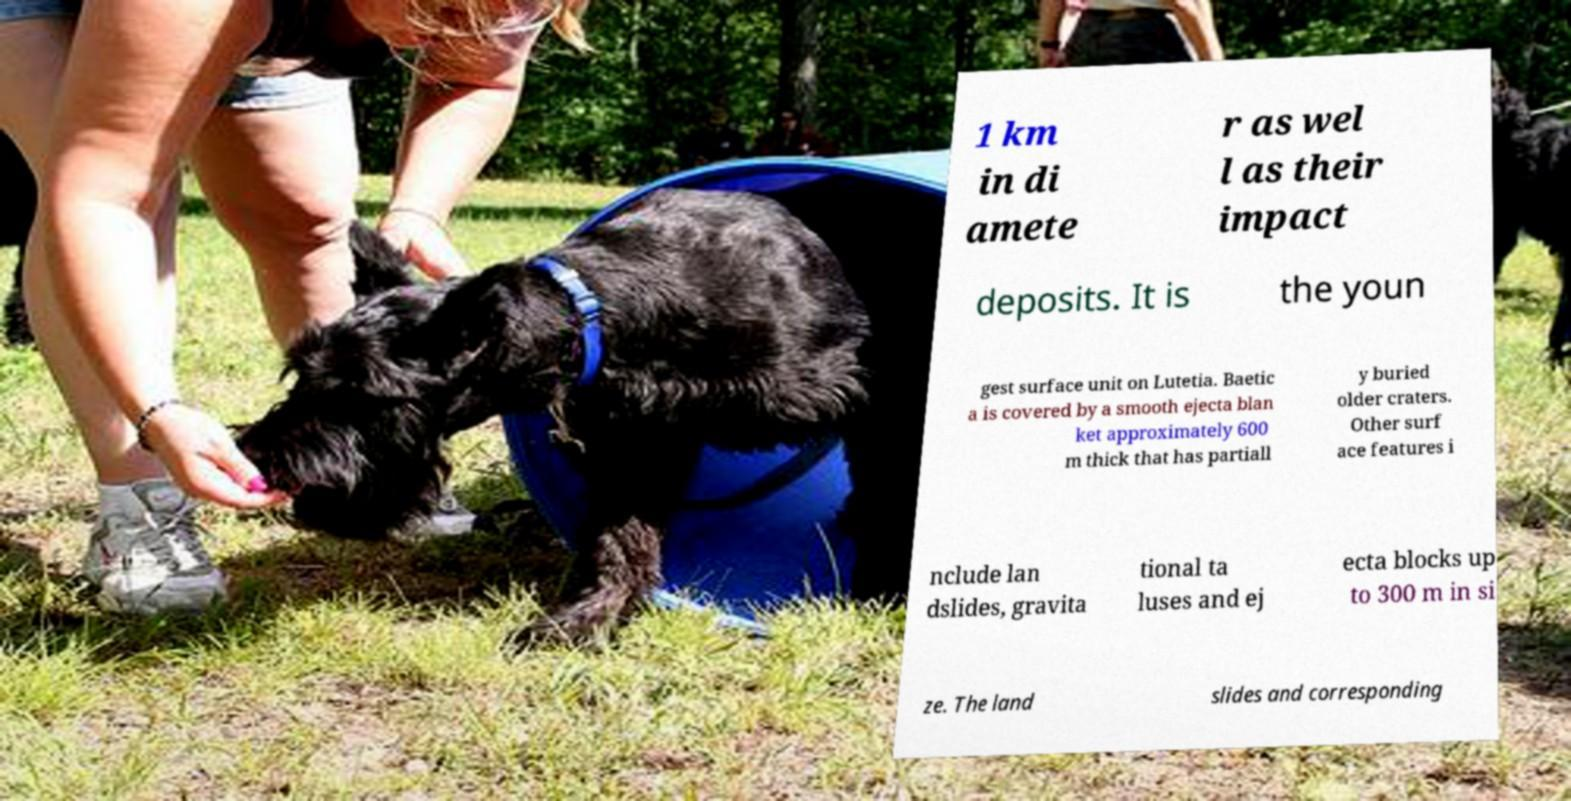Could you extract and type out the text from this image? 1 km in di amete r as wel l as their impact deposits. It is the youn gest surface unit on Lutetia. Baetic a is covered by a smooth ejecta blan ket approximately 600 m thick that has partiall y buried older craters. Other surf ace features i nclude lan dslides, gravita tional ta luses and ej ecta blocks up to 300 m in si ze. The land slides and corresponding 